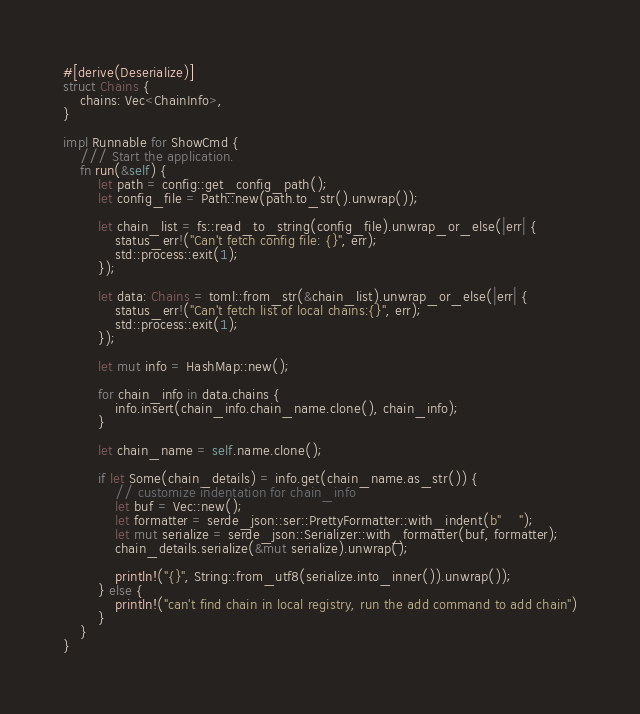Convert code to text. <code><loc_0><loc_0><loc_500><loc_500><_Rust_>#[derive(Deserialize)]
struct Chains {
    chains: Vec<ChainInfo>,
}

impl Runnable for ShowCmd {
    /// Start the application.
    fn run(&self) {
        let path = config::get_config_path();
        let config_file = Path::new(path.to_str().unwrap());

        let chain_list = fs::read_to_string(config_file).unwrap_or_else(|err| {
            status_err!("Can't fetch config file: {}", err);
            std::process::exit(1);
        });

        let data: Chains = toml::from_str(&chain_list).unwrap_or_else(|err| {
            status_err!("Can't fetch list of local chains:{}", err);
            std::process::exit(1);
        });

        let mut info = HashMap::new();

        for chain_info in data.chains {
            info.insert(chain_info.chain_name.clone(), chain_info);
        }

        let chain_name = self.name.clone();

        if let Some(chain_details) = info.get(chain_name.as_str()) {
            // customize indentation for chain_info
            let buf = Vec::new();
            let formatter = serde_json::ser::PrettyFormatter::with_indent(b"    ");
            let mut serialize = serde_json::Serializer::with_formatter(buf, formatter);
            chain_details.serialize(&mut serialize).unwrap();

            println!("{}", String::from_utf8(serialize.into_inner()).unwrap());
        } else {
            println!("can't find chain in local registry, run the add command to add chain")
        }
    }
}
</code> 